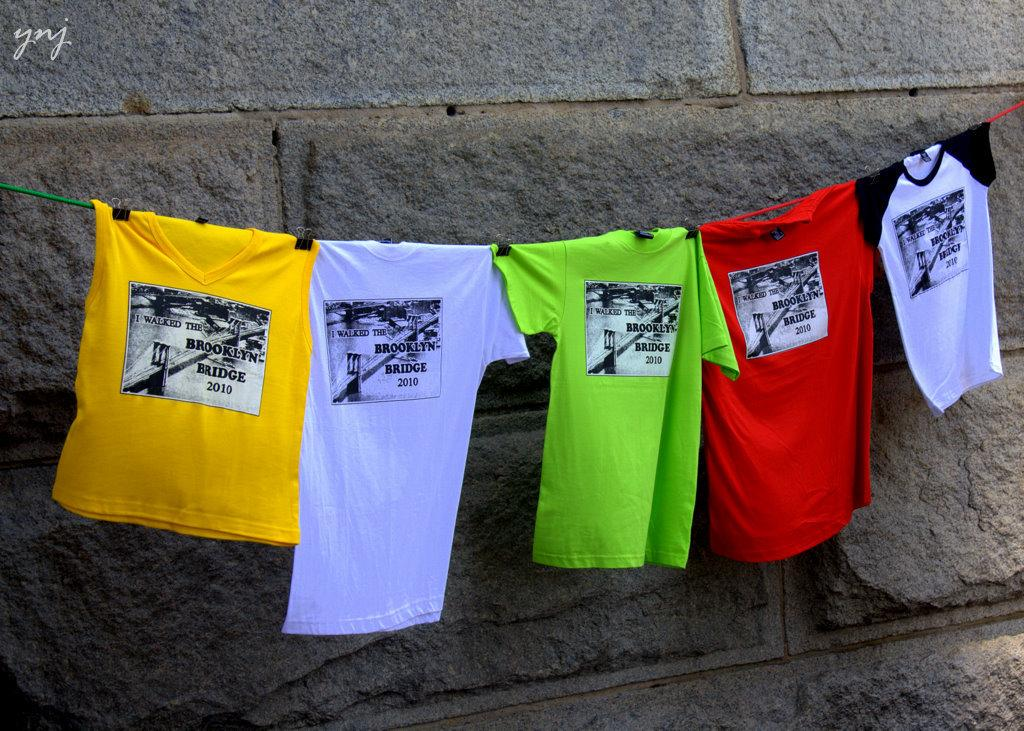<image>
Present a compact description of the photo's key features. 5 tshirts hang on a line that are printed with "I walked the Brooklyn Bridge 2010". 